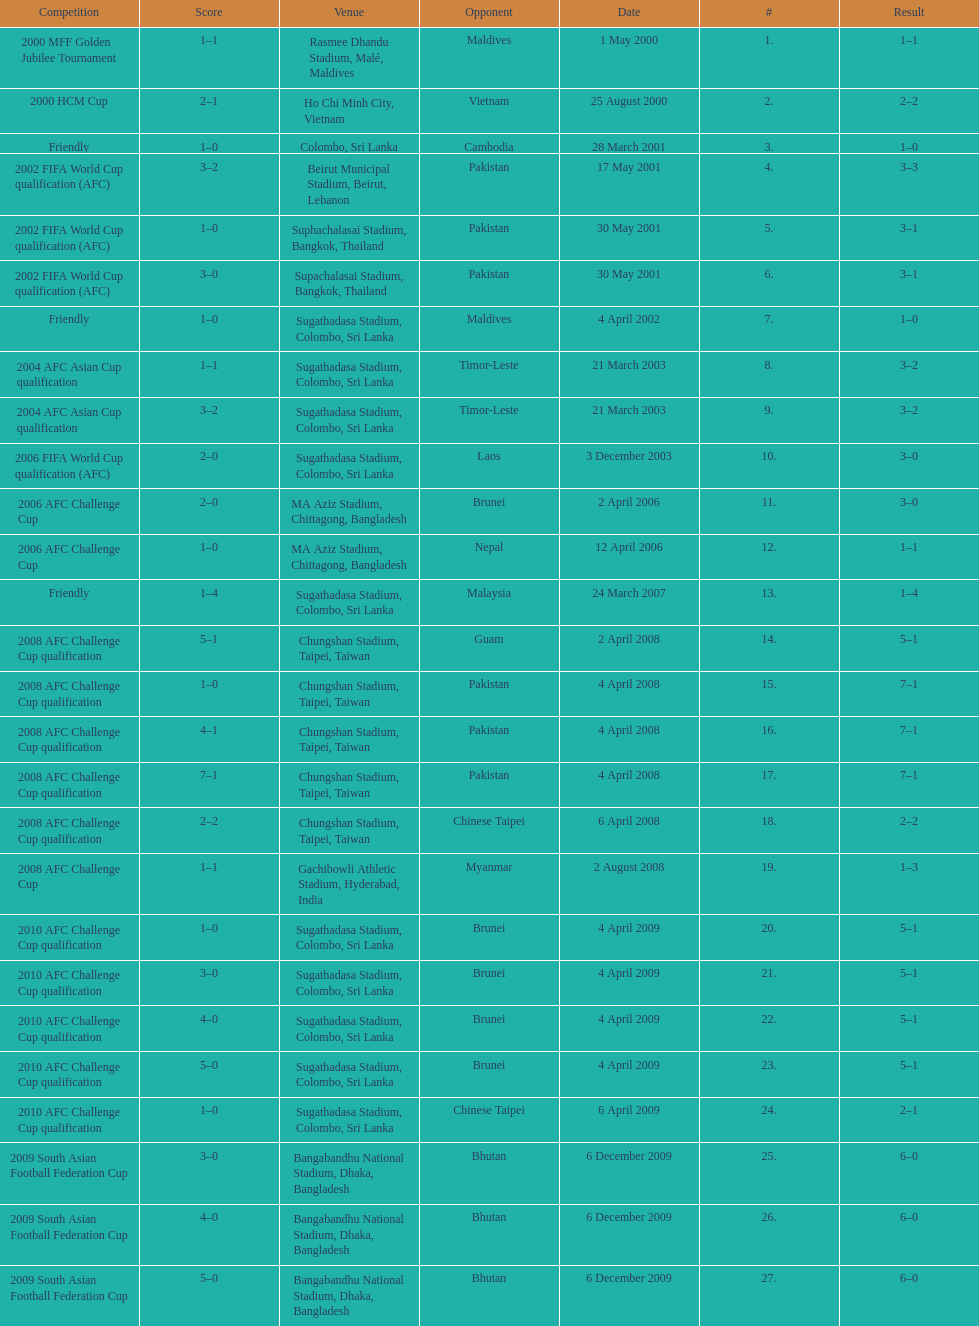In how many games did sri lanka score at least 2 goals? 16. 